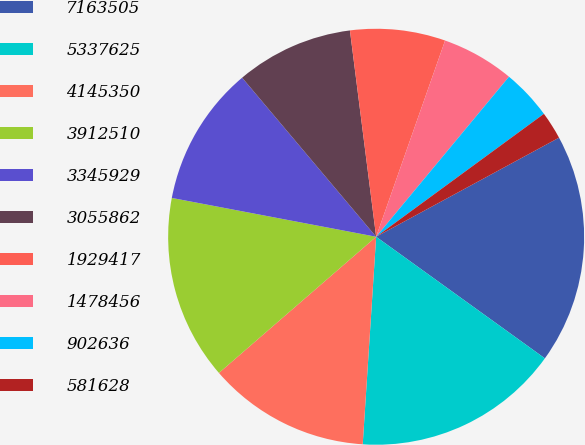<chart> <loc_0><loc_0><loc_500><loc_500><pie_chart><fcel>7163505<fcel>5337625<fcel>4145350<fcel>3912510<fcel>3345929<fcel>3055862<fcel>1929417<fcel>1478456<fcel>902636<fcel>581628<nl><fcel>17.84%<fcel>16.09%<fcel>12.61%<fcel>14.35%<fcel>10.87%<fcel>9.13%<fcel>7.39%<fcel>5.65%<fcel>3.91%<fcel>2.16%<nl></chart> 